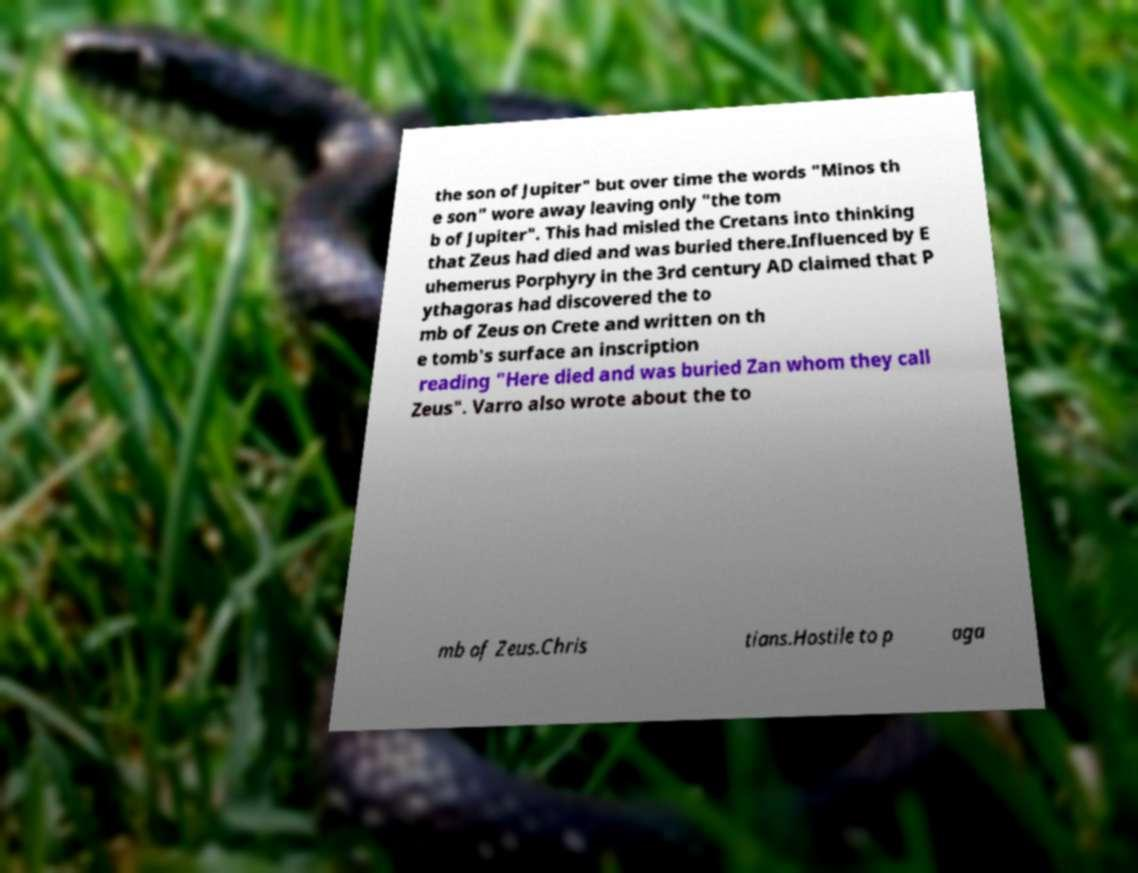Please identify and transcribe the text found in this image. the son of Jupiter" but over time the words "Minos th e son" wore away leaving only "the tom b of Jupiter". This had misled the Cretans into thinking that Zeus had died and was buried there.Influenced by E uhemerus Porphyry in the 3rd century AD claimed that P ythagoras had discovered the to mb of Zeus on Crete and written on th e tomb's surface an inscription reading "Here died and was buried Zan whom they call Zeus". Varro also wrote about the to mb of Zeus.Chris tians.Hostile to p aga 